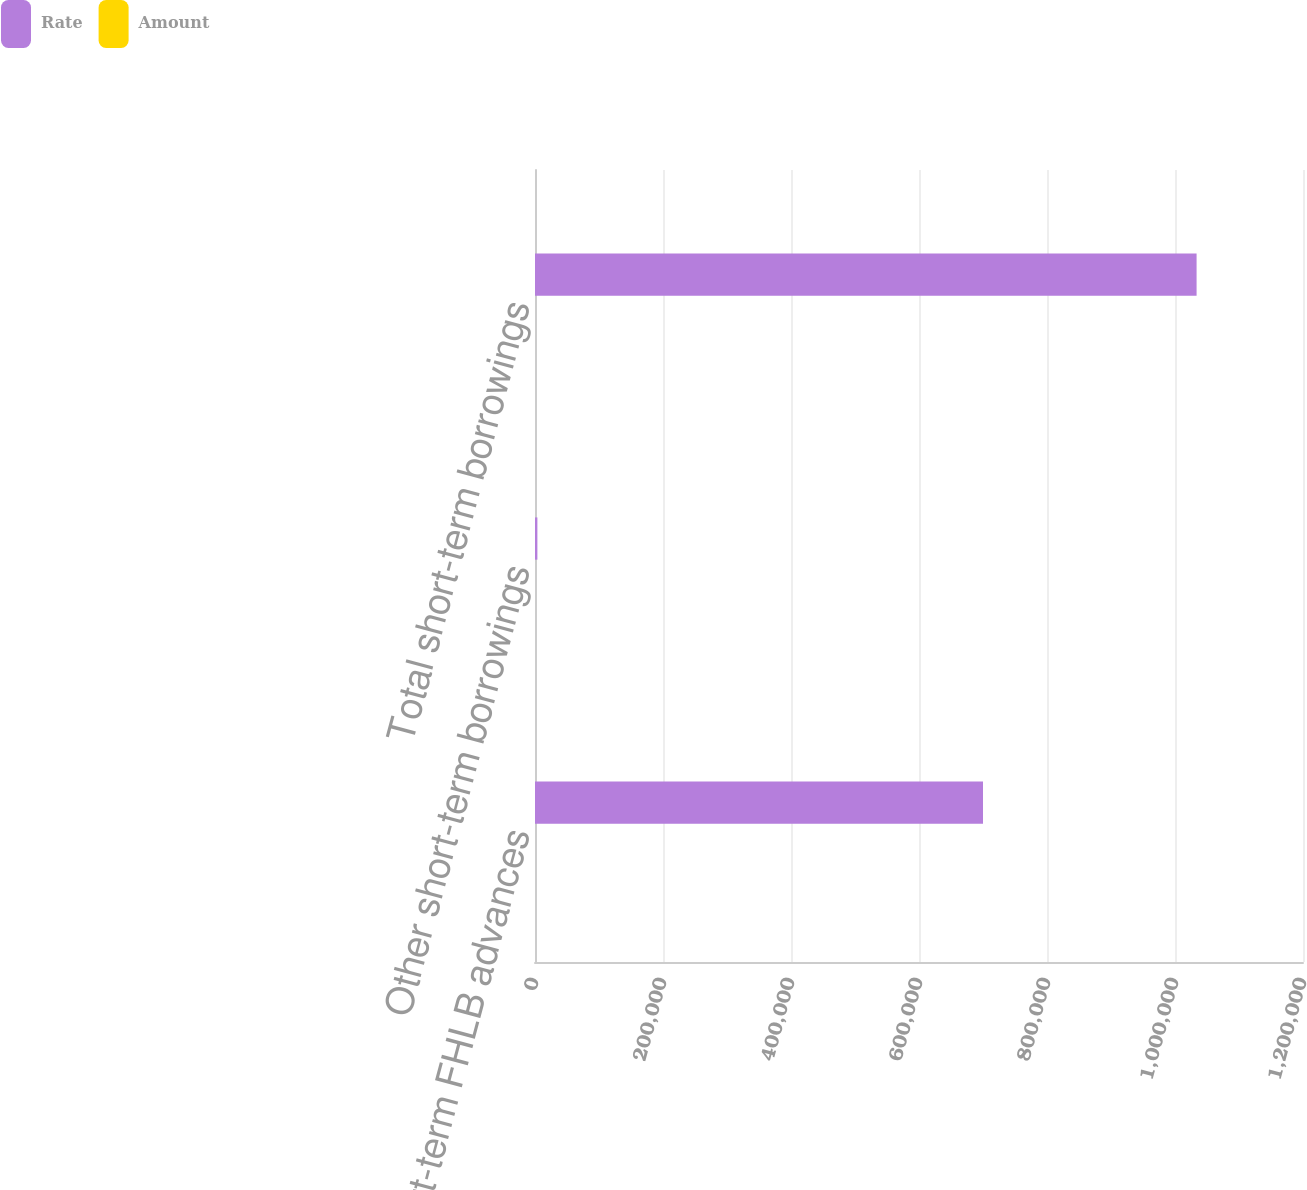Convert chart to OTSL. <chart><loc_0><loc_0><loc_500><loc_500><stacked_bar_chart><ecel><fcel>Short-term FHLB advances<fcel>Other short-term borrowings<fcel>Total short-term borrowings<nl><fcel>Rate<fcel>700000<fcel>3730<fcel>1.03373e+06<nl><fcel>Amount<fcel>1.37<fcel>1.33<fcel>1.39<nl></chart> 